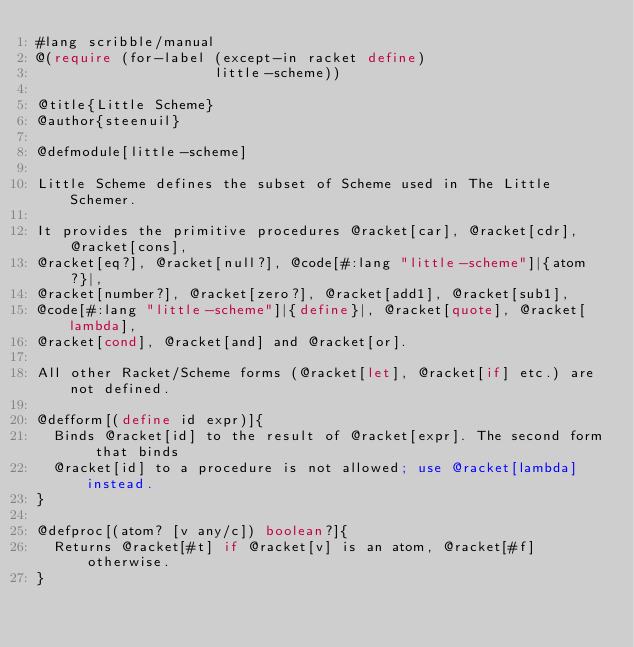<code> <loc_0><loc_0><loc_500><loc_500><_Racket_>#lang scribble/manual
@(require (for-label (except-in racket define)
                     little-scheme))

@title{Little Scheme}
@author{steenuil}

@defmodule[little-scheme]

Little Scheme defines the subset of Scheme used in The Little Schemer.

It provides the primitive procedures @racket[car], @racket[cdr], @racket[cons],
@racket[eq?], @racket[null?], @code[#:lang "little-scheme"]|{atom?}|,
@racket[number?], @racket[zero?], @racket[add1], @racket[sub1],
@code[#:lang "little-scheme"]|{define}|, @racket[quote], @racket[lambda],
@racket[cond], @racket[and] and @racket[or].

All other Racket/Scheme forms (@racket[let], @racket[if] etc.) are not defined.

@defform[(define id expr)]{
  Binds @racket[id] to the result of @racket[expr]. The second form that binds
  @racket[id] to a procedure is not allowed; use @racket[lambda] instead.
}

@defproc[(atom? [v any/c]) boolean?]{
  Returns @racket[#t] if @racket[v] is an atom, @racket[#f] otherwise.
}</code> 